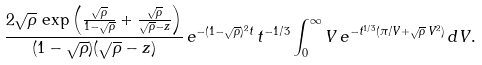Convert formula to latex. <formula><loc_0><loc_0><loc_500><loc_500>\frac { 2 \sqrt { \rho } \, \exp \left ( \frac { \sqrt { \rho } } { 1 - \sqrt { \rho } } + \frac { \sqrt { \rho } } { \sqrt { \rho } - z } \right ) } { ( 1 - \sqrt { \rho } ) ( \sqrt { \rho } - z ) } \, e ^ { - ( 1 - \sqrt { \rho } ) ^ { 2 } t } \, t ^ { - 1 / 3 } \int _ { 0 } ^ { \infty } V \, e ^ { - t ^ { 1 / 3 } ( \pi / V + \sqrt { \rho } \, V ^ { 2 } ) } \, d V .</formula> 